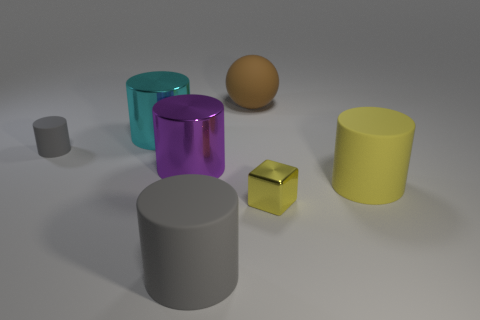Can you describe the arrangement of the objects in the scene? The objects are arranged somewhat haphazardly across the surface, without a discernible pattern, much like test objects in a three-dimensional software environment. 